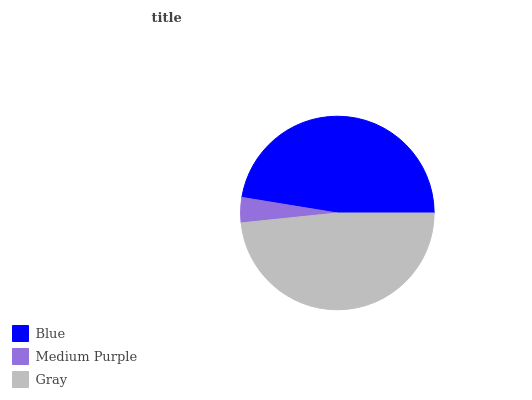Is Medium Purple the minimum?
Answer yes or no. Yes. Is Gray the maximum?
Answer yes or no. Yes. Is Gray the minimum?
Answer yes or no. No. Is Medium Purple the maximum?
Answer yes or no. No. Is Gray greater than Medium Purple?
Answer yes or no. Yes. Is Medium Purple less than Gray?
Answer yes or no. Yes. Is Medium Purple greater than Gray?
Answer yes or no. No. Is Gray less than Medium Purple?
Answer yes or no. No. Is Blue the high median?
Answer yes or no. Yes. Is Blue the low median?
Answer yes or no. Yes. Is Medium Purple the high median?
Answer yes or no. No. Is Gray the low median?
Answer yes or no. No. 